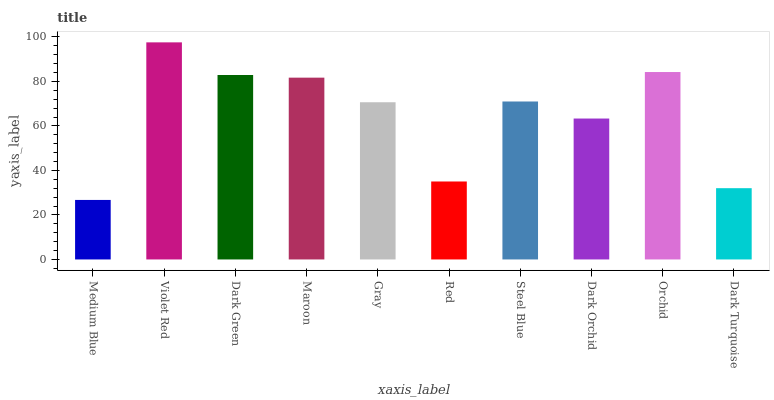Is Medium Blue the minimum?
Answer yes or no. Yes. Is Violet Red the maximum?
Answer yes or no. Yes. Is Dark Green the minimum?
Answer yes or no. No. Is Dark Green the maximum?
Answer yes or no. No. Is Violet Red greater than Dark Green?
Answer yes or no. Yes. Is Dark Green less than Violet Red?
Answer yes or no. Yes. Is Dark Green greater than Violet Red?
Answer yes or no. No. Is Violet Red less than Dark Green?
Answer yes or no. No. Is Steel Blue the high median?
Answer yes or no. Yes. Is Gray the low median?
Answer yes or no. Yes. Is Gray the high median?
Answer yes or no. No. Is Steel Blue the low median?
Answer yes or no. No. 